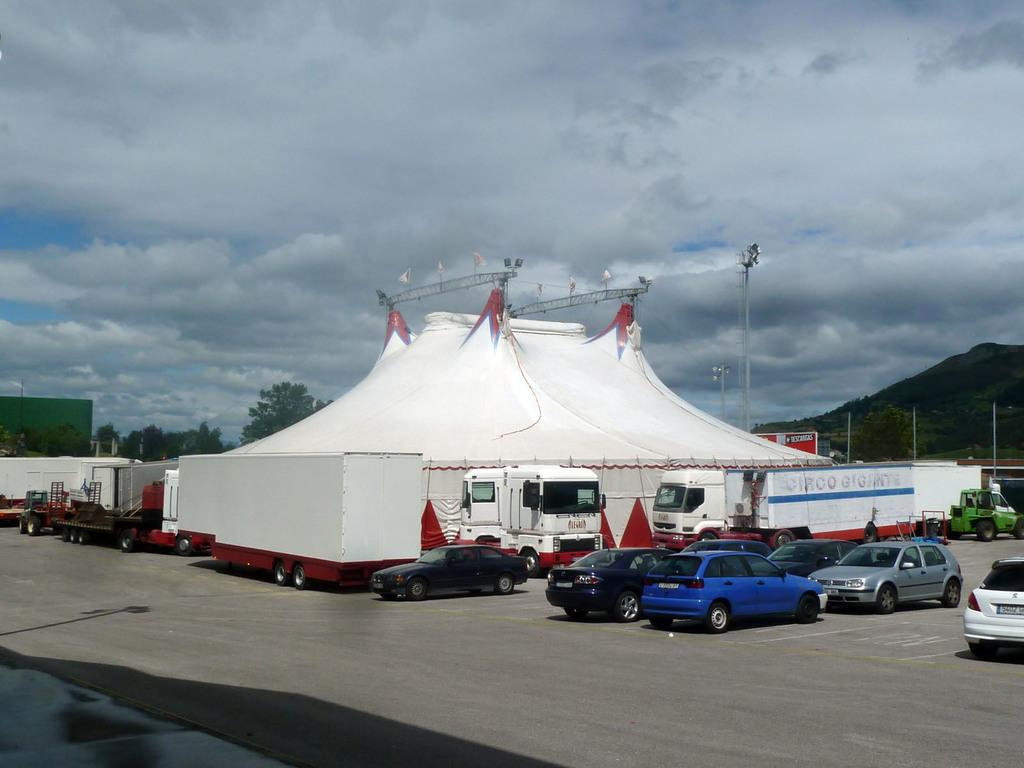What can be seen on the road in the image? There are vehicles on the road in the image. What type of temporary shelters are present in the image? There are tents in the image. What structures can be seen in the image? There are poles in the image. What type of natural vegetation is present in the image? There are trees in the image. What geographical feature is visible in the image? There is a mountain in the image. What else is present in the image besides the mentioned objects? There are objects in the image. What is visible in the background of the image? The sky is visible in the background of the image. What can be seen in the sky? Clouds are present in the sky. Where is the hammer located in the image? There is no hammer present in the image. What shape is the bag in the image? There is no bag present in the image. 